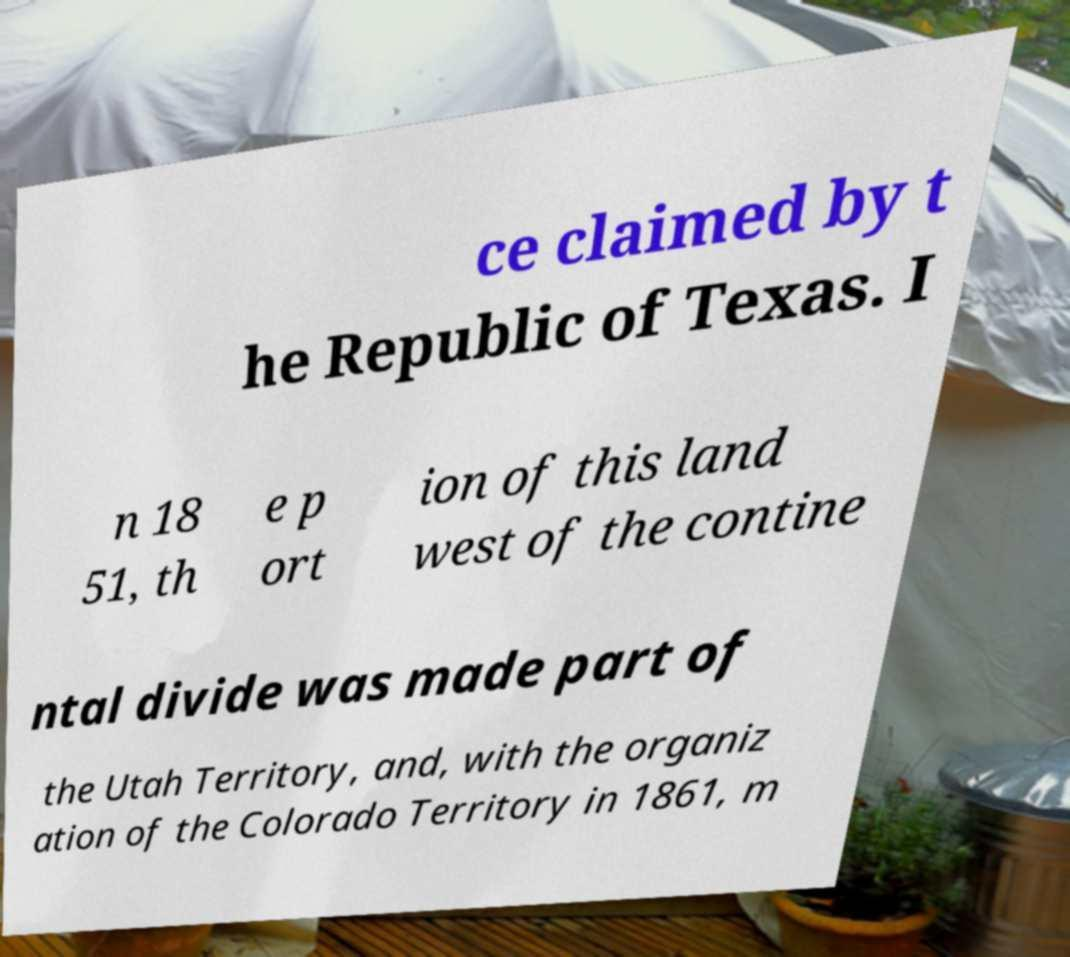Please identify and transcribe the text found in this image. ce claimed by t he Republic of Texas. I n 18 51, th e p ort ion of this land west of the contine ntal divide was made part of the Utah Territory, and, with the organiz ation of the Colorado Territory in 1861, m 